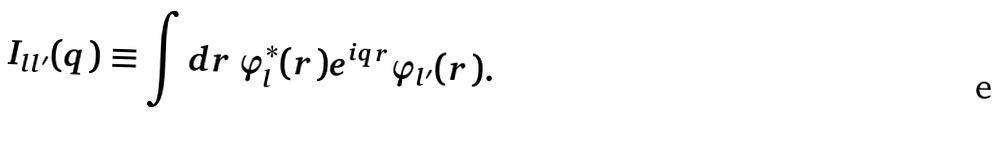Convert formula to latex. <formula><loc_0><loc_0><loc_500><loc_500>I _ { l l ^ { \prime } } ( { q } ) \equiv \int d { r } \, \varphi ^ { * } _ { l } ( { r } ) e ^ { i { q r } } \varphi _ { l ^ { \prime } } ( { r } ) .</formula> 